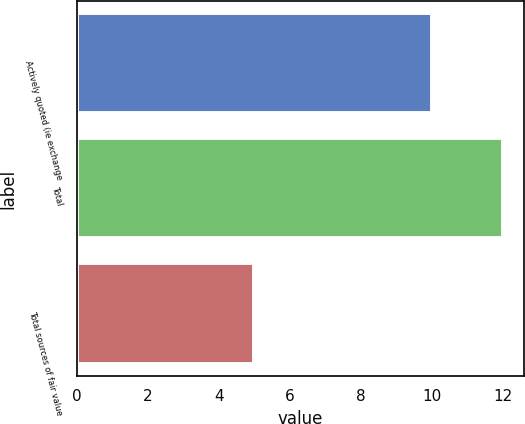<chart> <loc_0><loc_0><loc_500><loc_500><bar_chart><fcel>Actively quoted (ie exchange<fcel>Total<fcel>Total sources of fair value<nl><fcel>10<fcel>12<fcel>5<nl></chart> 